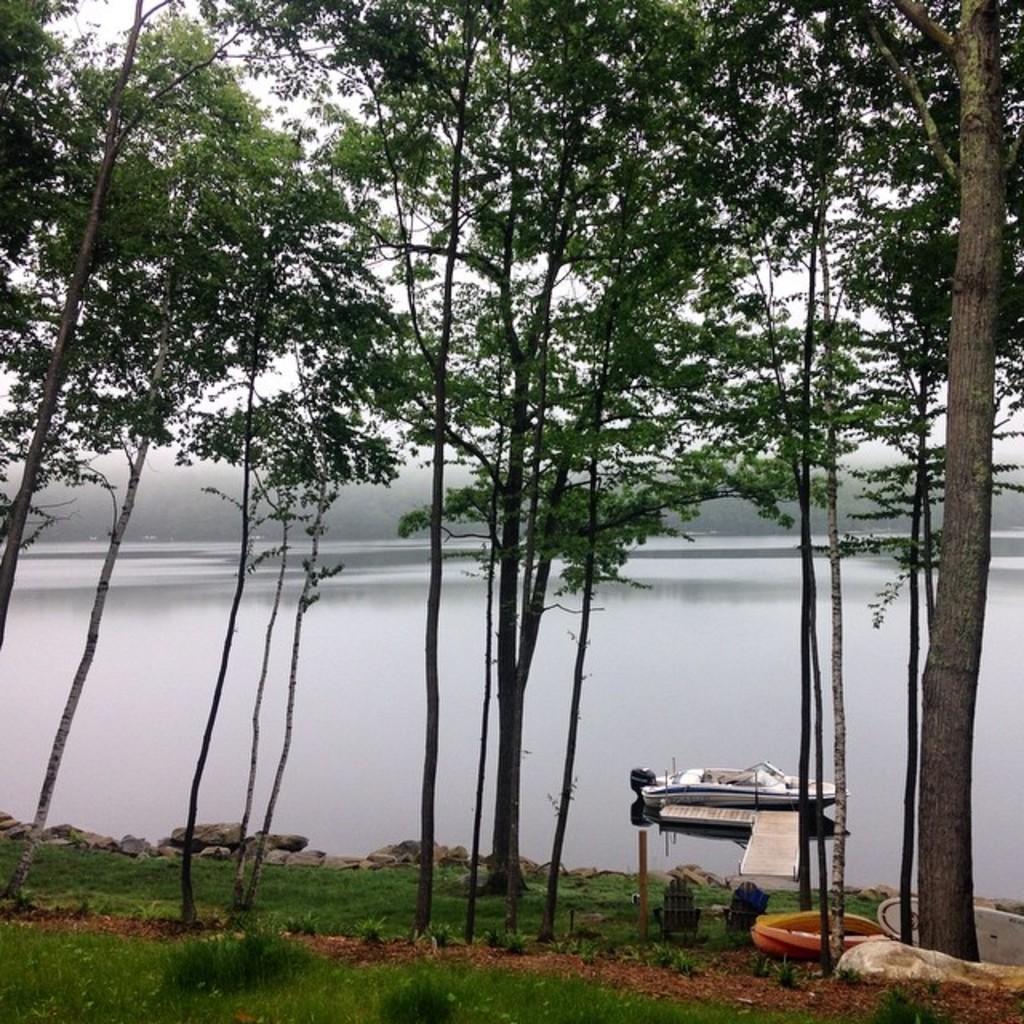Please provide a concise description of this image. In this picture, we see a boat in the water and this water might be a river. Beside that, there are trees and stones. At the bottom of the picture, we see grass. In the background, we see the sky. 